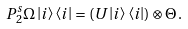Convert formula to latex. <formula><loc_0><loc_0><loc_500><loc_500>P ^ { s } _ { 2 } \Omega \left | i \right \rangle \left \langle i \right | = ( U \left | i \right \rangle \left \langle i \right | ) \otimes \Theta \, .</formula> 